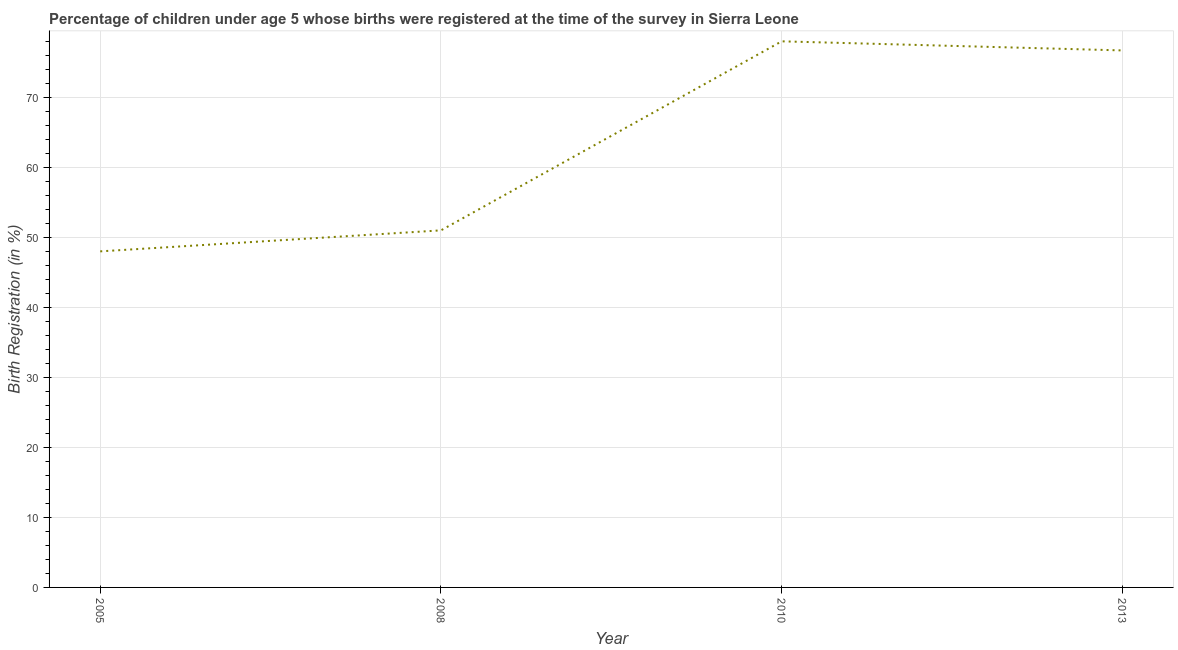Across all years, what is the minimum birth registration?
Give a very brief answer. 48. In which year was the birth registration maximum?
Offer a terse response. 2010. What is the sum of the birth registration?
Your response must be concise. 253.7. What is the difference between the birth registration in 2005 and 2010?
Offer a very short reply. -30. What is the average birth registration per year?
Give a very brief answer. 63.42. What is the median birth registration?
Ensure brevity in your answer.  63.85. In how many years, is the birth registration greater than 72 %?
Make the answer very short. 2. Do a majority of the years between 2005 and 2008 (inclusive) have birth registration greater than 48 %?
Your answer should be very brief. No. What is the ratio of the birth registration in 2005 to that in 2010?
Your answer should be very brief. 0.62. Is the birth registration in 2005 less than that in 2008?
Offer a terse response. Yes. What is the difference between the highest and the second highest birth registration?
Offer a terse response. 1.3. Is the sum of the birth registration in 2010 and 2013 greater than the maximum birth registration across all years?
Make the answer very short. Yes. What is the difference between the highest and the lowest birth registration?
Offer a very short reply. 30. Does the birth registration monotonically increase over the years?
Offer a terse response. No. How many years are there in the graph?
Offer a terse response. 4. What is the difference between two consecutive major ticks on the Y-axis?
Offer a very short reply. 10. Are the values on the major ticks of Y-axis written in scientific E-notation?
Your answer should be compact. No. Does the graph contain grids?
Provide a short and direct response. Yes. What is the title of the graph?
Your response must be concise. Percentage of children under age 5 whose births were registered at the time of the survey in Sierra Leone. What is the label or title of the Y-axis?
Provide a succinct answer. Birth Registration (in %). What is the Birth Registration (in %) of 2005?
Give a very brief answer. 48. What is the Birth Registration (in %) in 2008?
Your answer should be very brief. 51. What is the Birth Registration (in %) in 2010?
Make the answer very short. 78. What is the Birth Registration (in %) in 2013?
Keep it short and to the point. 76.7. What is the difference between the Birth Registration (in %) in 2005 and 2008?
Make the answer very short. -3. What is the difference between the Birth Registration (in %) in 2005 and 2010?
Provide a succinct answer. -30. What is the difference between the Birth Registration (in %) in 2005 and 2013?
Offer a terse response. -28.7. What is the difference between the Birth Registration (in %) in 2008 and 2013?
Keep it short and to the point. -25.7. What is the difference between the Birth Registration (in %) in 2010 and 2013?
Your response must be concise. 1.3. What is the ratio of the Birth Registration (in %) in 2005 to that in 2008?
Your answer should be compact. 0.94. What is the ratio of the Birth Registration (in %) in 2005 to that in 2010?
Keep it short and to the point. 0.61. What is the ratio of the Birth Registration (in %) in 2005 to that in 2013?
Your response must be concise. 0.63. What is the ratio of the Birth Registration (in %) in 2008 to that in 2010?
Your answer should be very brief. 0.65. What is the ratio of the Birth Registration (in %) in 2008 to that in 2013?
Ensure brevity in your answer.  0.67. 